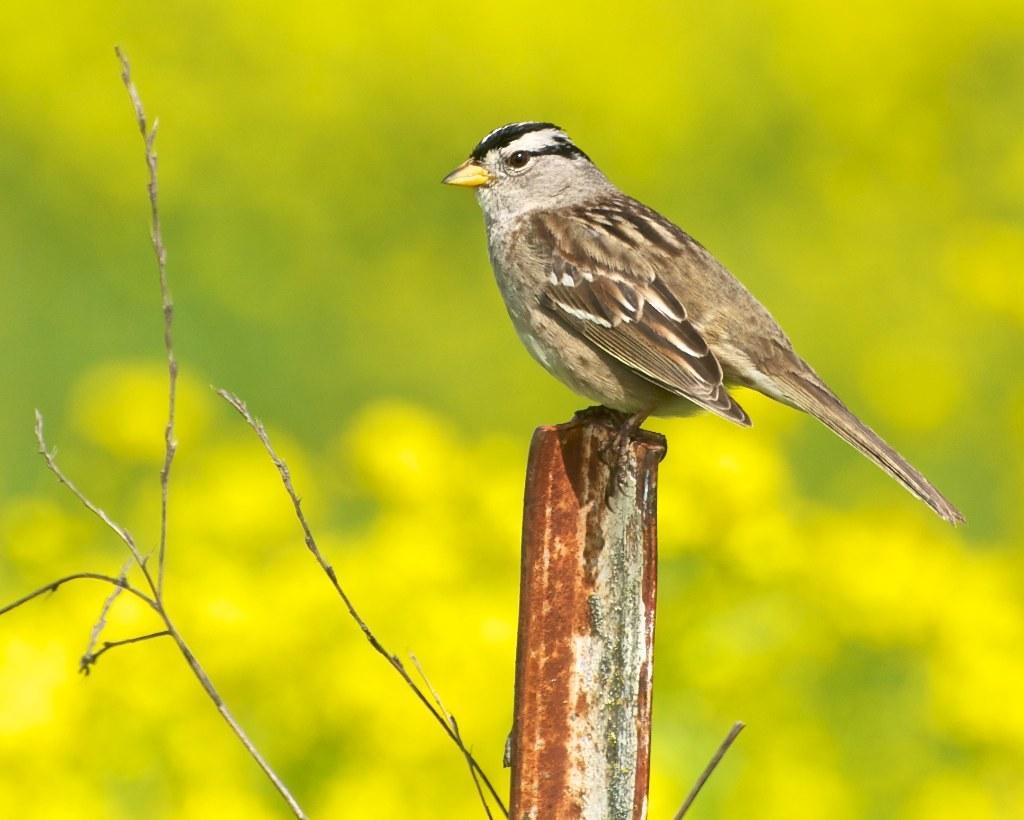What type of bird is in the image? There is a sparrow in the image. What is the color of the sparrow? The sparrow is brown in color. What features can be observed on the sparrow? The sparrow has an eye and a tail. How would you describe the background of the image? The background of the image is blurry. What type of prose can be seen in the image? There is no prose present in the image; it features a sparrow with a blurry background. What kind of pies are being served at the place depicted in the image? There is no place or pies depicted in the image; it only shows a sparrow. 